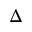Convert formula to latex. <formula><loc_0><loc_0><loc_500><loc_500>\Delta</formula> 